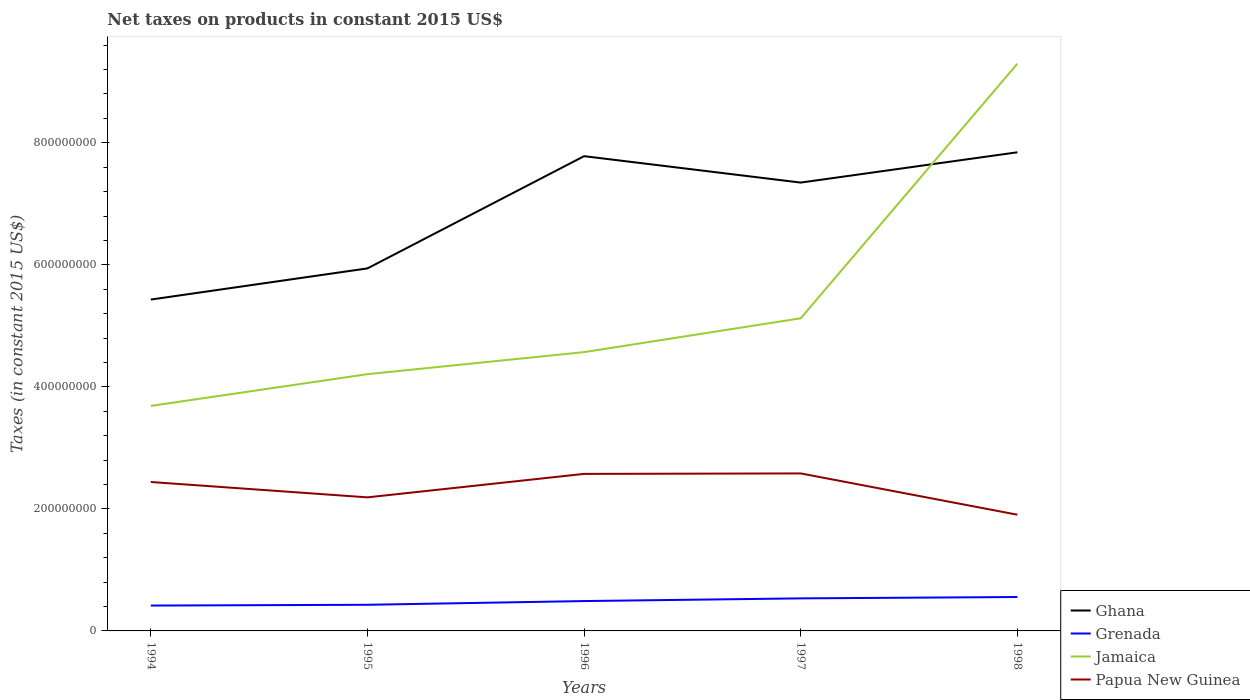How many different coloured lines are there?
Offer a very short reply. 4. Across all years, what is the maximum net taxes on products in Jamaica?
Make the answer very short. 3.69e+08. In which year was the net taxes on products in Grenada maximum?
Your answer should be compact. 1994. What is the total net taxes on products in Grenada in the graph?
Your answer should be compact. -1.18e+07. What is the difference between the highest and the second highest net taxes on products in Grenada?
Ensure brevity in your answer.  1.40e+07. Are the values on the major ticks of Y-axis written in scientific E-notation?
Your answer should be very brief. No. Where does the legend appear in the graph?
Keep it short and to the point. Bottom right. What is the title of the graph?
Your answer should be very brief. Net taxes on products in constant 2015 US$. What is the label or title of the X-axis?
Keep it short and to the point. Years. What is the label or title of the Y-axis?
Your answer should be very brief. Taxes (in constant 2015 US$). What is the Taxes (in constant 2015 US$) of Ghana in 1994?
Offer a terse response. 5.43e+08. What is the Taxes (in constant 2015 US$) of Grenada in 1994?
Make the answer very short. 4.16e+07. What is the Taxes (in constant 2015 US$) of Jamaica in 1994?
Offer a very short reply. 3.69e+08. What is the Taxes (in constant 2015 US$) in Papua New Guinea in 1994?
Your answer should be compact. 2.44e+08. What is the Taxes (in constant 2015 US$) in Ghana in 1995?
Your answer should be very brief. 5.94e+08. What is the Taxes (in constant 2015 US$) of Grenada in 1995?
Your answer should be very brief. 4.29e+07. What is the Taxes (in constant 2015 US$) of Jamaica in 1995?
Make the answer very short. 4.21e+08. What is the Taxes (in constant 2015 US$) of Papua New Guinea in 1995?
Offer a very short reply. 2.19e+08. What is the Taxes (in constant 2015 US$) of Ghana in 1996?
Offer a terse response. 7.78e+08. What is the Taxes (in constant 2015 US$) in Grenada in 1996?
Offer a terse response. 4.89e+07. What is the Taxes (in constant 2015 US$) of Jamaica in 1996?
Keep it short and to the point. 4.57e+08. What is the Taxes (in constant 2015 US$) in Papua New Guinea in 1996?
Your response must be concise. 2.57e+08. What is the Taxes (in constant 2015 US$) in Ghana in 1997?
Keep it short and to the point. 7.35e+08. What is the Taxes (in constant 2015 US$) of Grenada in 1997?
Make the answer very short. 5.33e+07. What is the Taxes (in constant 2015 US$) in Jamaica in 1997?
Your response must be concise. 5.12e+08. What is the Taxes (in constant 2015 US$) in Papua New Guinea in 1997?
Make the answer very short. 2.58e+08. What is the Taxes (in constant 2015 US$) of Ghana in 1998?
Offer a very short reply. 7.84e+08. What is the Taxes (in constant 2015 US$) in Grenada in 1998?
Offer a terse response. 5.56e+07. What is the Taxes (in constant 2015 US$) of Jamaica in 1998?
Offer a terse response. 9.30e+08. What is the Taxes (in constant 2015 US$) in Papua New Guinea in 1998?
Provide a succinct answer. 1.90e+08. Across all years, what is the maximum Taxes (in constant 2015 US$) of Ghana?
Give a very brief answer. 7.84e+08. Across all years, what is the maximum Taxes (in constant 2015 US$) in Grenada?
Provide a succinct answer. 5.56e+07. Across all years, what is the maximum Taxes (in constant 2015 US$) in Jamaica?
Your answer should be very brief. 9.30e+08. Across all years, what is the maximum Taxes (in constant 2015 US$) of Papua New Guinea?
Your response must be concise. 2.58e+08. Across all years, what is the minimum Taxes (in constant 2015 US$) in Ghana?
Provide a succinct answer. 5.43e+08. Across all years, what is the minimum Taxes (in constant 2015 US$) in Grenada?
Give a very brief answer. 4.16e+07. Across all years, what is the minimum Taxes (in constant 2015 US$) of Jamaica?
Keep it short and to the point. 3.69e+08. Across all years, what is the minimum Taxes (in constant 2015 US$) of Papua New Guinea?
Your response must be concise. 1.90e+08. What is the total Taxes (in constant 2015 US$) in Ghana in the graph?
Make the answer very short. 3.43e+09. What is the total Taxes (in constant 2015 US$) in Grenada in the graph?
Provide a short and direct response. 2.42e+08. What is the total Taxes (in constant 2015 US$) in Jamaica in the graph?
Provide a short and direct response. 2.69e+09. What is the total Taxes (in constant 2015 US$) in Papua New Guinea in the graph?
Provide a succinct answer. 1.17e+09. What is the difference between the Taxes (in constant 2015 US$) of Ghana in 1994 and that in 1995?
Provide a short and direct response. -5.11e+07. What is the difference between the Taxes (in constant 2015 US$) in Grenada in 1994 and that in 1995?
Give a very brief answer. -1.30e+06. What is the difference between the Taxes (in constant 2015 US$) in Jamaica in 1994 and that in 1995?
Your answer should be compact. -5.20e+07. What is the difference between the Taxes (in constant 2015 US$) in Papua New Guinea in 1994 and that in 1995?
Keep it short and to the point. 2.52e+07. What is the difference between the Taxes (in constant 2015 US$) in Ghana in 1994 and that in 1996?
Offer a terse response. -2.35e+08. What is the difference between the Taxes (in constant 2015 US$) of Grenada in 1994 and that in 1996?
Provide a succinct answer. -7.39e+06. What is the difference between the Taxes (in constant 2015 US$) of Jamaica in 1994 and that in 1996?
Provide a succinct answer. -8.81e+07. What is the difference between the Taxes (in constant 2015 US$) of Papua New Guinea in 1994 and that in 1996?
Give a very brief answer. -1.33e+07. What is the difference between the Taxes (in constant 2015 US$) in Ghana in 1994 and that in 1997?
Your response must be concise. -1.92e+08. What is the difference between the Taxes (in constant 2015 US$) of Grenada in 1994 and that in 1997?
Your answer should be very brief. -1.18e+07. What is the difference between the Taxes (in constant 2015 US$) of Jamaica in 1994 and that in 1997?
Your answer should be compact. -1.44e+08. What is the difference between the Taxes (in constant 2015 US$) of Papua New Guinea in 1994 and that in 1997?
Make the answer very short. -1.41e+07. What is the difference between the Taxes (in constant 2015 US$) of Ghana in 1994 and that in 1998?
Your answer should be compact. -2.41e+08. What is the difference between the Taxes (in constant 2015 US$) of Grenada in 1994 and that in 1998?
Your answer should be compact. -1.40e+07. What is the difference between the Taxes (in constant 2015 US$) in Jamaica in 1994 and that in 1998?
Your answer should be very brief. -5.61e+08. What is the difference between the Taxes (in constant 2015 US$) of Papua New Guinea in 1994 and that in 1998?
Your response must be concise. 5.36e+07. What is the difference between the Taxes (in constant 2015 US$) in Ghana in 1995 and that in 1996?
Provide a succinct answer. -1.84e+08. What is the difference between the Taxes (in constant 2015 US$) of Grenada in 1995 and that in 1996?
Your response must be concise. -6.10e+06. What is the difference between the Taxes (in constant 2015 US$) of Jamaica in 1995 and that in 1996?
Provide a succinct answer. -3.61e+07. What is the difference between the Taxes (in constant 2015 US$) in Papua New Guinea in 1995 and that in 1996?
Your response must be concise. -3.85e+07. What is the difference between the Taxes (in constant 2015 US$) in Ghana in 1995 and that in 1997?
Ensure brevity in your answer.  -1.41e+08. What is the difference between the Taxes (in constant 2015 US$) in Grenada in 1995 and that in 1997?
Your answer should be very brief. -1.05e+07. What is the difference between the Taxes (in constant 2015 US$) of Jamaica in 1995 and that in 1997?
Provide a short and direct response. -9.16e+07. What is the difference between the Taxes (in constant 2015 US$) of Papua New Guinea in 1995 and that in 1997?
Offer a terse response. -3.92e+07. What is the difference between the Taxes (in constant 2015 US$) in Ghana in 1995 and that in 1998?
Give a very brief answer. -1.90e+08. What is the difference between the Taxes (in constant 2015 US$) in Grenada in 1995 and that in 1998?
Your response must be concise. -1.27e+07. What is the difference between the Taxes (in constant 2015 US$) of Jamaica in 1995 and that in 1998?
Your answer should be compact. -5.09e+08. What is the difference between the Taxes (in constant 2015 US$) of Papua New Guinea in 1995 and that in 1998?
Your answer should be very brief. 2.85e+07. What is the difference between the Taxes (in constant 2015 US$) of Ghana in 1996 and that in 1997?
Keep it short and to the point. 4.33e+07. What is the difference between the Taxes (in constant 2015 US$) of Grenada in 1996 and that in 1997?
Keep it short and to the point. -4.39e+06. What is the difference between the Taxes (in constant 2015 US$) in Jamaica in 1996 and that in 1997?
Make the answer very short. -5.55e+07. What is the difference between the Taxes (in constant 2015 US$) in Papua New Guinea in 1996 and that in 1997?
Give a very brief answer. -7.72e+05. What is the difference between the Taxes (in constant 2015 US$) in Ghana in 1996 and that in 1998?
Your answer should be very brief. -6.37e+06. What is the difference between the Taxes (in constant 2015 US$) of Grenada in 1996 and that in 1998?
Your response must be concise. -6.61e+06. What is the difference between the Taxes (in constant 2015 US$) of Jamaica in 1996 and that in 1998?
Make the answer very short. -4.73e+08. What is the difference between the Taxes (in constant 2015 US$) of Papua New Guinea in 1996 and that in 1998?
Keep it short and to the point. 6.69e+07. What is the difference between the Taxes (in constant 2015 US$) in Ghana in 1997 and that in 1998?
Make the answer very short. -4.97e+07. What is the difference between the Taxes (in constant 2015 US$) in Grenada in 1997 and that in 1998?
Keep it short and to the point. -2.23e+06. What is the difference between the Taxes (in constant 2015 US$) in Jamaica in 1997 and that in 1998?
Ensure brevity in your answer.  -4.17e+08. What is the difference between the Taxes (in constant 2015 US$) of Papua New Guinea in 1997 and that in 1998?
Make the answer very short. 6.77e+07. What is the difference between the Taxes (in constant 2015 US$) of Ghana in 1994 and the Taxes (in constant 2015 US$) of Grenada in 1995?
Keep it short and to the point. 5.00e+08. What is the difference between the Taxes (in constant 2015 US$) in Ghana in 1994 and the Taxes (in constant 2015 US$) in Jamaica in 1995?
Give a very brief answer. 1.22e+08. What is the difference between the Taxes (in constant 2015 US$) in Ghana in 1994 and the Taxes (in constant 2015 US$) in Papua New Guinea in 1995?
Ensure brevity in your answer.  3.24e+08. What is the difference between the Taxes (in constant 2015 US$) in Grenada in 1994 and the Taxes (in constant 2015 US$) in Jamaica in 1995?
Offer a terse response. -3.79e+08. What is the difference between the Taxes (in constant 2015 US$) of Grenada in 1994 and the Taxes (in constant 2015 US$) of Papua New Guinea in 1995?
Your answer should be compact. -1.77e+08. What is the difference between the Taxes (in constant 2015 US$) in Jamaica in 1994 and the Taxes (in constant 2015 US$) in Papua New Guinea in 1995?
Give a very brief answer. 1.50e+08. What is the difference between the Taxes (in constant 2015 US$) in Ghana in 1994 and the Taxes (in constant 2015 US$) in Grenada in 1996?
Give a very brief answer. 4.94e+08. What is the difference between the Taxes (in constant 2015 US$) of Ghana in 1994 and the Taxes (in constant 2015 US$) of Jamaica in 1996?
Give a very brief answer. 8.61e+07. What is the difference between the Taxes (in constant 2015 US$) in Ghana in 1994 and the Taxes (in constant 2015 US$) in Papua New Guinea in 1996?
Your answer should be compact. 2.86e+08. What is the difference between the Taxes (in constant 2015 US$) in Grenada in 1994 and the Taxes (in constant 2015 US$) in Jamaica in 1996?
Your response must be concise. -4.15e+08. What is the difference between the Taxes (in constant 2015 US$) in Grenada in 1994 and the Taxes (in constant 2015 US$) in Papua New Guinea in 1996?
Your answer should be very brief. -2.16e+08. What is the difference between the Taxes (in constant 2015 US$) of Jamaica in 1994 and the Taxes (in constant 2015 US$) of Papua New Guinea in 1996?
Your answer should be compact. 1.11e+08. What is the difference between the Taxes (in constant 2015 US$) in Ghana in 1994 and the Taxes (in constant 2015 US$) in Grenada in 1997?
Ensure brevity in your answer.  4.90e+08. What is the difference between the Taxes (in constant 2015 US$) in Ghana in 1994 and the Taxes (in constant 2015 US$) in Jamaica in 1997?
Keep it short and to the point. 3.07e+07. What is the difference between the Taxes (in constant 2015 US$) in Ghana in 1994 and the Taxes (in constant 2015 US$) in Papua New Guinea in 1997?
Offer a very short reply. 2.85e+08. What is the difference between the Taxes (in constant 2015 US$) of Grenada in 1994 and the Taxes (in constant 2015 US$) of Jamaica in 1997?
Your answer should be very brief. -4.71e+08. What is the difference between the Taxes (in constant 2015 US$) in Grenada in 1994 and the Taxes (in constant 2015 US$) in Papua New Guinea in 1997?
Offer a terse response. -2.17e+08. What is the difference between the Taxes (in constant 2015 US$) in Jamaica in 1994 and the Taxes (in constant 2015 US$) in Papua New Guinea in 1997?
Your answer should be very brief. 1.11e+08. What is the difference between the Taxes (in constant 2015 US$) in Ghana in 1994 and the Taxes (in constant 2015 US$) in Grenada in 1998?
Offer a terse response. 4.88e+08. What is the difference between the Taxes (in constant 2015 US$) of Ghana in 1994 and the Taxes (in constant 2015 US$) of Jamaica in 1998?
Offer a very short reply. -3.87e+08. What is the difference between the Taxes (in constant 2015 US$) of Ghana in 1994 and the Taxes (in constant 2015 US$) of Papua New Guinea in 1998?
Offer a very short reply. 3.53e+08. What is the difference between the Taxes (in constant 2015 US$) in Grenada in 1994 and the Taxes (in constant 2015 US$) in Jamaica in 1998?
Provide a succinct answer. -8.88e+08. What is the difference between the Taxes (in constant 2015 US$) in Grenada in 1994 and the Taxes (in constant 2015 US$) in Papua New Guinea in 1998?
Provide a short and direct response. -1.49e+08. What is the difference between the Taxes (in constant 2015 US$) in Jamaica in 1994 and the Taxes (in constant 2015 US$) in Papua New Guinea in 1998?
Your answer should be very brief. 1.78e+08. What is the difference between the Taxes (in constant 2015 US$) in Ghana in 1995 and the Taxes (in constant 2015 US$) in Grenada in 1996?
Give a very brief answer. 5.45e+08. What is the difference between the Taxes (in constant 2015 US$) in Ghana in 1995 and the Taxes (in constant 2015 US$) in Jamaica in 1996?
Provide a short and direct response. 1.37e+08. What is the difference between the Taxes (in constant 2015 US$) of Ghana in 1995 and the Taxes (in constant 2015 US$) of Papua New Guinea in 1996?
Offer a very short reply. 3.37e+08. What is the difference between the Taxes (in constant 2015 US$) in Grenada in 1995 and the Taxes (in constant 2015 US$) in Jamaica in 1996?
Provide a short and direct response. -4.14e+08. What is the difference between the Taxes (in constant 2015 US$) in Grenada in 1995 and the Taxes (in constant 2015 US$) in Papua New Guinea in 1996?
Make the answer very short. -2.15e+08. What is the difference between the Taxes (in constant 2015 US$) in Jamaica in 1995 and the Taxes (in constant 2015 US$) in Papua New Guinea in 1996?
Make the answer very short. 1.63e+08. What is the difference between the Taxes (in constant 2015 US$) in Ghana in 1995 and the Taxes (in constant 2015 US$) in Grenada in 1997?
Give a very brief answer. 5.41e+08. What is the difference between the Taxes (in constant 2015 US$) of Ghana in 1995 and the Taxes (in constant 2015 US$) of Jamaica in 1997?
Give a very brief answer. 8.18e+07. What is the difference between the Taxes (in constant 2015 US$) in Ghana in 1995 and the Taxes (in constant 2015 US$) in Papua New Guinea in 1997?
Provide a succinct answer. 3.36e+08. What is the difference between the Taxes (in constant 2015 US$) of Grenada in 1995 and the Taxes (in constant 2015 US$) of Jamaica in 1997?
Your response must be concise. -4.70e+08. What is the difference between the Taxes (in constant 2015 US$) in Grenada in 1995 and the Taxes (in constant 2015 US$) in Papua New Guinea in 1997?
Offer a very short reply. -2.15e+08. What is the difference between the Taxes (in constant 2015 US$) in Jamaica in 1995 and the Taxes (in constant 2015 US$) in Papua New Guinea in 1997?
Make the answer very short. 1.63e+08. What is the difference between the Taxes (in constant 2015 US$) in Ghana in 1995 and the Taxes (in constant 2015 US$) in Grenada in 1998?
Provide a short and direct response. 5.39e+08. What is the difference between the Taxes (in constant 2015 US$) of Ghana in 1995 and the Taxes (in constant 2015 US$) of Jamaica in 1998?
Your answer should be compact. -3.36e+08. What is the difference between the Taxes (in constant 2015 US$) of Ghana in 1995 and the Taxes (in constant 2015 US$) of Papua New Guinea in 1998?
Your answer should be compact. 4.04e+08. What is the difference between the Taxes (in constant 2015 US$) of Grenada in 1995 and the Taxes (in constant 2015 US$) of Jamaica in 1998?
Your answer should be very brief. -8.87e+08. What is the difference between the Taxes (in constant 2015 US$) of Grenada in 1995 and the Taxes (in constant 2015 US$) of Papua New Guinea in 1998?
Your response must be concise. -1.48e+08. What is the difference between the Taxes (in constant 2015 US$) of Jamaica in 1995 and the Taxes (in constant 2015 US$) of Papua New Guinea in 1998?
Provide a short and direct response. 2.30e+08. What is the difference between the Taxes (in constant 2015 US$) in Ghana in 1996 and the Taxes (in constant 2015 US$) in Grenada in 1997?
Give a very brief answer. 7.25e+08. What is the difference between the Taxes (in constant 2015 US$) of Ghana in 1996 and the Taxes (in constant 2015 US$) of Jamaica in 1997?
Offer a very short reply. 2.66e+08. What is the difference between the Taxes (in constant 2015 US$) of Ghana in 1996 and the Taxes (in constant 2015 US$) of Papua New Guinea in 1997?
Your answer should be very brief. 5.20e+08. What is the difference between the Taxes (in constant 2015 US$) of Grenada in 1996 and the Taxes (in constant 2015 US$) of Jamaica in 1997?
Give a very brief answer. -4.63e+08. What is the difference between the Taxes (in constant 2015 US$) of Grenada in 1996 and the Taxes (in constant 2015 US$) of Papua New Guinea in 1997?
Your answer should be very brief. -2.09e+08. What is the difference between the Taxes (in constant 2015 US$) of Jamaica in 1996 and the Taxes (in constant 2015 US$) of Papua New Guinea in 1997?
Keep it short and to the point. 1.99e+08. What is the difference between the Taxes (in constant 2015 US$) of Ghana in 1996 and the Taxes (in constant 2015 US$) of Grenada in 1998?
Your answer should be very brief. 7.23e+08. What is the difference between the Taxes (in constant 2015 US$) of Ghana in 1996 and the Taxes (in constant 2015 US$) of Jamaica in 1998?
Ensure brevity in your answer.  -1.52e+08. What is the difference between the Taxes (in constant 2015 US$) in Ghana in 1996 and the Taxes (in constant 2015 US$) in Papua New Guinea in 1998?
Make the answer very short. 5.88e+08. What is the difference between the Taxes (in constant 2015 US$) of Grenada in 1996 and the Taxes (in constant 2015 US$) of Jamaica in 1998?
Ensure brevity in your answer.  -8.81e+08. What is the difference between the Taxes (in constant 2015 US$) of Grenada in 1996 and the Taxes (in constant 2015 US$) of Papua New Guinea in 1998?
Give a very brief answer. -1.42e+08. What is the difference between the Taxes (in constant 2015 US$) of Jamaica in 1996 and the Taxes (in constant 2015 US$) of Papua New Guinea in 1998?
Your response must be concise. 2.66e+08. What is the difference between the Taxes (in constant 2015 US$) in Ghana in 1997 and the Taxes (in constant 2015 US$) in Grenada in 1998?
Make the answer very short. 6.79e+08. What is the difference between the Taxes (in constant 2015 US$) of Ghana in 1997 and the Taxes (in constant 2015 US$) of Jamaica in 1998?
Your answer should be very brief. -1.95e+08. What is the difference between the Taxes (in constant 2015 US$) in Ghana in 1997 and the Taxes (in constant 2015 US$) in Papua New Guinea in 1998?
Provide a succinct answer. 5.44e+08. What is the difference between the Taxes (in constant 2015 US$) in Grenada in 1997 and the Taxes (in constant 2015 US$) in Jamaica in 1998?
Give a very brief answer. -8.76e+08. What is the difference between the Taxes (in constant 2015 US$) of Grenada in 1997 and the Taxes (in constant 2015 US$) of Papua New Guinea in 1998?
Give a very brief answer. -1.37e+08. What is the difference between the Taxes (in constant 2015 US$) in Jamaica in 1997 and the Taxes (in constant 2015 US$) in Papua New Guinea in 1998?
Give a very brief answer. 3.22e+08. What is the average Taxes (in constant 2015 US$) in Ghana per year?
Keep it short and to the point. 6.87e+08. What is the average Taxes (in constant 2015 US$) of Grenada per year?
Provide a succinct answer. 4.85e+07. What is the average Taxes (in constant 2015 US$) in Jamaica per year?
Make the answer very short. 5.38e+08. What is the average Taxes (in constant 2015 US$) of Papua New Guinea per year?
Make the answer very short. 2.34e+08. In the year 1994, what is the difference between the Taxes (in constant 2015 US$) in Ghana and Taxes (in constant 2015 US$) in Grenada?
Offer a very short reply. 5.02e+08. In the year 1994, what is the difference between the Taxes (in constant 2015 US$) of Ghana and Taxes (in constant 2015 US$) of Jamaica?
Offer a very short reply. 1.74e+08. In the year 1994, what is the difference between the Taxes (in constant 2015 US$) of Ghana and Taxes (in constant 2015 US$) of Papua New Guinea?
Keep it short and to the point. 2.99e+08. In the year 1994, what is the difference between the Taxes (in constant 2015 US$) in Grenada and Taxes (in constant 2015 US$) in Jamaica?
Offer a terse response. -3.27e+08. In the year 1994, what is the difference between the Taxes (in constant 2015 US$) in Grenada and Taxes (in constant 2015 US$) in Papua New Guinea?
Give a very brief answer. -2.03e+08. In the year 1994, what is the difference between the Taxes (in constant 2015 US$) of Jamaica and Taxes (in constant 2015 US$) of Papua New Guinea?
Give a very brief answer. 1.25e+08. In the year 1995, what is the difference between the Taxes (in constant 2015 US$) of Ghana and Taxes (in constant 2015 US$) of Grenada?
Provide a succinct answer. 5.51e+08. In the year 1995, what is the difference between the Taxes (in constant 2015 US$) in Ghana and Taxes (in constant 2015 US$) in Jamaica?
Offer a very short reply. 1.73e+08. In the year 1995, what is the difference between the Taxes (in constant 2015 US$) of Ghana and Taxes (in constant 2015 US$) of Papua New Guinea?
Make the answer very short. 3.75e+08. In the year 1995, what is the difference between the Taxes (in constant 2015 US$) of Grenada and Taxes (in constant 2015 US$) of Jamaica?
Ensure brevity in your answer.  -3.78e+08. In the year 1995, what is the difference between the Taxes (in constant 2015 US$) in Grenada and Taxes (in constant 2015 US$) in Papua New Guinea?
Provide a short and direct response. -1.76e+08. In the year 1995, what is the difference between the Taxes (in constant 2015 US$) of Jamaica and Taxes (in constant 2015 US$) of Papua New Guinea?
Offer a very short reply. 2.02e+08. In the year 1996, what is the difference between the Taxes (in constant 2015 US$) in Ghana and Taxes (in constant 2015 US$) in Grenada?
Your answer should be compact. 7.29e+08. In the year 1996, what is the difference between the Taxes (in constant 2015 US$) in Ghana and Taxes (in constant 2015 US$) in Jamaica?
Provide a short and direct response. 3.21e+08. In the year 1996, what is the difference between the Taxes (in constant 2015 US$) in Ghana and Taxes (in constant 2015 US$) in Papua New Guinea?
Offer a terse response. 5.21e+08. In the year 1996, what is the difference between the Taxes (in constant 2015 US$) in Grenada and Taxes (in constant 2015 US$) in Jamaica?
Keep it short and to the point. -4.08e+08. In the year 1996, what is the difference between the Taxes (in constant 2015 US$) of Grenada and Taxes (in constant 2015 US$) of Papua New Guinea?
Offer a very short reply. -2.08e+08. In the year 1996, what is the difference between the Taxes (in constant 2015 US$) in Jamaica and Taxes (in constant 2015 US$) in Papua New Guinea?
Ensure brevity in your answer.  2.00e+08. In the year 1997, what is the difference between the Taxes (in constant 2015 US$) of Ghana and Taxes (in constant 2015 US$) of Grenada?
Your answer should be very brief. 6.81e+08. In the year 1997, what is the difference between the Taxes (in constant 2015 US$) of Ghana and Taxes (in constant 2015 US$) of Jamaica?
Provide a short and direct response. 2.22e+08. In the year 1997, what is the difference between the Taxes (in constant 2015 US$) of Ghana and Taxes (in constant 2015 US$) of Papua New Guinea?
Ensure brevity in your answer.  4.77e+08. In the year 1997, what is the difference between the Taxes (in constant 2015 US$) in Grenada and Taxes (in constant 2015 US$) in Jamaica?
Offer a very short reply. -4.59e+08. In the year 1997, what is the difference between the Taxes (in constant 2015 US$) of Grenada and Taxes (in constant 2015 US$) of Papua New Guinea?
Your answer should be compact. -2.05e+08. In the year 1997, what is the difference between the Taxes (in constant 2015 US$) in Jamaica and Taxes (in constant 2015 US$) in Papua New Guinea?
Your answer should be compact. 2.54e+08. In the year 1998, what is the difference between the Taxes (in constant 2015 US$) of Ghana and Taxes (in constant 2015 US$) of Grenada?
Provide a short and direct response. 7.29e+08. In the year 1998, what is the difference between the Taxes (in constant 2015 US$) in Ghana and Taxes (in constant 2015 US$) in Jamaica?
Your response must be concise. -1.45e+08. In the year 1998, what is the difference between the Taxes (in constant 2015 US$) in Ghana and Taxes (in constant 2015 US$) in Papua New Guinea?
Your answer should be compact. 5.94e+08. In the year 1998, what is the difference between the Taxes (in constant 2015 US$) of Grenada and Taxes (in constant 2015 US$) of Jamaica?
Provide a succinct answer. -8.74e+08. In the year 1998, what is the difference between the Taxes (in constant 2015 US$) of Grenada and Taxes (in constant 2015 US$) of Papua New Guinea?
Your answer should be very brief. -1.35e+08. In the year 1998, what is the difference between the Taxes (in constant 2015 US$) of Jamaica and Taxes (in constant 2015 US$) of Papua New Guinea?
Your answer should be compact. 7.39e+08. What is the ratio of the Taxes (in constant 2015 US$) in Ghana in 1994 to that in 1995?
Provide a succinct answer. 0.91. What is the ratio of the Taxes (in constant 2015 US$) in Grenada in 1994 to that in 1995?
Make the answer very short. 0.97. What is the ratio of the Taxes (in constant 2015 US$) of Jamaica in 1994 to that in 1995?
Offer a terse response. 0.88. What is the ratio of the Taxes (in constant 2015 US$) of Papua New Guinea in 1994 to that in 1995?
Your answer should be compact. 1.11. What is the ratio of the Taxes (in constant 2015 US$) in Ghana in 1994 to that in 1996?
Your answer should be compact. 0.7. What is the ratio of the Taxes (in constant 2015 US$) of Grenada in 1994 to that in 1996?
Offer a very short reply. 0.85. What is the ratio of the Taxes (in constant 2015 US$) in Jamaica in 1994 to that in 1996?
Your answer should be compact. 0.81. What is the ratio of the Taxes (in constant 2015 US$) of Papua New Guinea in 1994 to that in 1996?
Offer a terse response. 0.95. What is the ratio of the Taxes (in constant 2015 US$) of Ghana in 1994 to that in 1997?
Make the answer very short. 0.74. What is the ratio of the Taxes (in constant 2015 US$) of Grenada in 1994 to that in 1997?
Your answer should be compact. 0.78. What is the ratio of the Taxes (in constant 2015 US$) of Jamaica in 1994 to that in 1997?
Your response must be concise. 0.72. What is the ratio of the Taxes (in constant 2015 US$) of Papua New Guinea in 1994 to that in 1997?
Make the answer very short. 0.95. What is the ratio of the Taxes (in constant 2015 US$) of Ghana in 1994 to that in 1998?
Provide a succinct answer. 0.69. What is the ratio of the Taxes (in constant 2015 US$) in Grenada in 1994 to that in 1998?
Your answer should be compact. 0.75. What is the ratio of the Taxes (in constant 2015 US$) of Jamaica in 1994 to that in 1998?
Your answer should be compact. 0.4. What is the ratio of the Taxes (in constant 2015 US$) in Papua New Guinea in 1994 to that in 1998?
Keep it short and to the point. 1.28. What is the ratio of the Taxes (in constant 2015 US$) in Ghana in 1995 to that in 1996?
Offer a terse response. 0.76. What is the ratio of the Taxes (in constant 2015 US$) in Grenada in 1995 to that in 1996?
Your answer should be very brief. 0.88. What is the ratio of the Taxes (in constant 2015 US$) of Jamaica in 1995 to that in 1996?
Give a very brief answer. 0.92. What is the ratio of the Taxes (in constant 2015 US$) in Papua New Guinea in 1995 to that in 1996?
Keep it short and to the point. 0.85. What is the ratio of the Taxes (in constant 2015 US$) of Ghana in 1995 to that in 1997?
Offer a terse response. 0.81. What is the ratio of the Taxes (in constant 2015 US$) of Grenada in 1995 to that in 1997?
Provide a succinct answer. 0.8. What is the ratio of the Taxes (in constant 2015 US$) of Jamaica in 1995 to that in 1997?
Make the answer very short. 0.82. What is the ratio of the Taxes (in constant 2015 US$) of Papua New Guinea in 1995 to that in 1997?
Offer a very short reply. 0.85. What is the ratio of the Taxes (in constant 2015 US$) in Ghana in 1995 to that in 1998?
Offer a very short reply. 0.76. What is the ratio of the Taxes (in constant 2015 US$) in Grenada in 1995 to that in 1998?
Provide a succinct answer. 0.77. What is the ratio of the Taxes (in constant 2015 US$) of Jamaica in 1995 to that in 1998?
Provide a succinct answer. 0.45. What is the ratio of the Taxes (in constant 2015 US$) of Papua New Guinea in 1995 to that in 1998?
Keep it short and to the point. 1.15. What is the ratio of the Taxes (in constant 2015 US$) of Ghana in 1996 to that in 1997?
Your answer should be compact. 1.06. What is the ratio of the Taxes (in constant 2015 US$) in Grenada in 1996 to that in 1997?
Your response must be concise. 0.92. What is the ratio of the Taxes (in constant 2015 US$) in Jamaica in 1996 to that in 1997?
Your response must be concise. 0.89. What is the ratio of the Taxes (in constant 2015 US$) of Ghana in 1996 to that in 1998?
Make the answer very short. 0.99. What is the ratio of the Taxes (in constant 2015 US$) of Grenada in 1996 to that in 1998?
Provide a short and direct response. 0.88. What is the ratio of the Taxes (in constant 2015 US$) of Jamaica in 1996 to that in 1998?
Provide a short and direct response. 0.49. What is the ratio of the Taxes (in constant 2015 US$) in Papua New Guinea in 1996 to that in 1998?
Make the answer very short. 1.35. What is the ratio of the Taxes (in constant 2015 US$) of Ghana in 1997 to that in 1998?
Offer a very short reply. 0.94. What is the ratio of the Taxes (in constant 2015 US$) of Grenada in 1997 to that in 1998?
Your response must be concise. 0.96. What is the ratio of the Taxes (in constant 2015 US$) of Jamaica in 1997 to that in 1998?
Ensure brevity in your answer.  0.55. What is the ratio of the Taxes (in constant 2015 US$) of Papua New Guinea in 1997 to that in 1998?
Ensure brevity in your answer.  1.36. What is the difference between the highest and the second highest Taxes (in constant 2015 US$) of Ghana?
Offer a very short reply. 6.37e+06. What is the difference between the highest and the second highest Taxes (in constant 2015 US$) in Grenada?
Provide a short and direct response. 2.23e+06. What is the difference between the highest and the second highest Taxes (in constant 2015 US$) of Jamaica?
Give a very brief answer. 4.17e+08. What is the difference between the highest and the second highest Taxes (in constant 2015 US$) of Papua New Guinea?
Provide a succinct answer. 7.72e+05. What is the difference between the highest and the lowest Taxes (in constant 2015 US$) in Ghana?
Provide a short and direct response. 2.41e+08. What is the difference between the highest and the lowest Taxes (in constant 2015 US$) of Grenada?
Make the answer very short. 1.40e+07. What is the difference between the highest and the lowest Taxes (in constant 2015 US$) of Jamaica?
Give a very brief answer. 5.61e+08. What is the difference between the highest and the lowest Taxes (in constant 2015 US$) in Papua New Guinea?
Your answer should be very brief. 6.77e+07. 